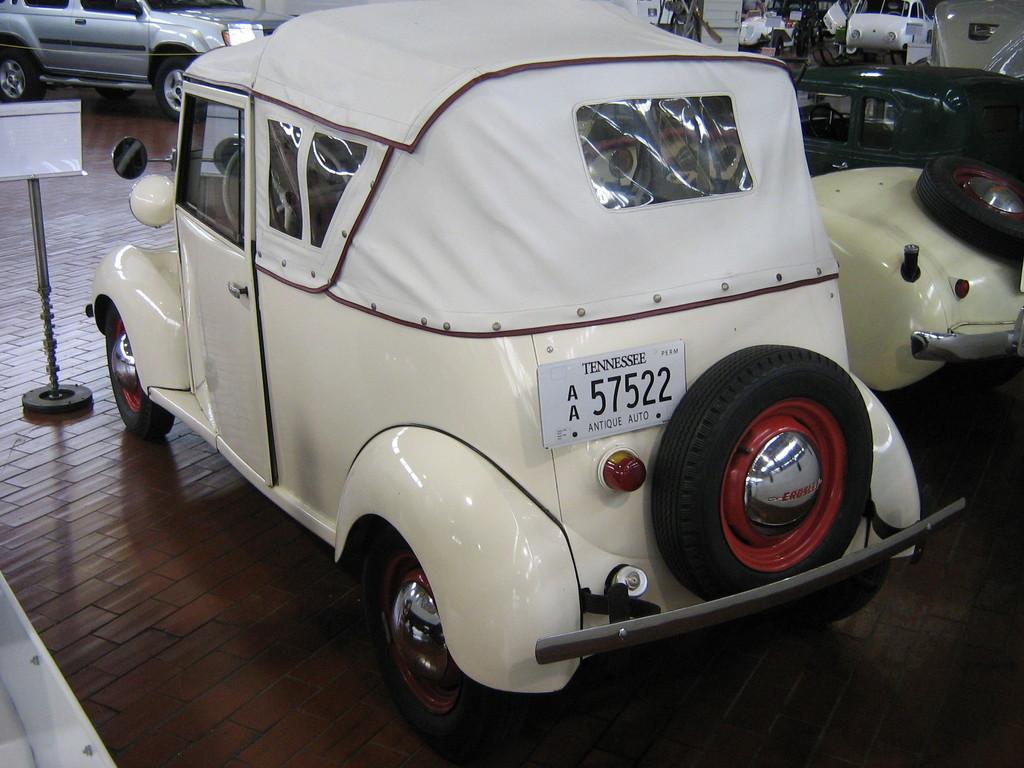Please provide a concise description of this image. In this picture we can see vintage cars and other vehicles parked on the wooden floor. 